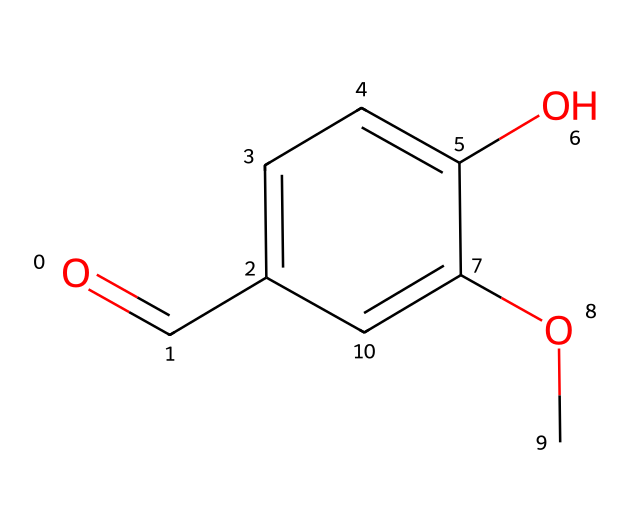What is the common name of this chemical? The chemical structure corresponds to vanillin, which is a well-known flavoring and fragrance compound derived from vanilla beans.
Answer: vanillin How many carbon atoms are in this molecule? By analyzing the SMILES representation, we can count the number of 'C's. There are 8 carbon atoms present in the structure.
Answer: 8 What functional groups are present in this compound? The chemical contains a hydroxyl group (-OH), an aldehyde group (-CHO), and a methoxy group (-OCH3), which are responsible for its aroma and flavor properties.
Answer: hydroxyl, aldehyde, methoxy How many hydrogen atoms are connected to carbon atoms in this molecule? Counting the hydrogen atoms, we see that each carbon's typical valency of four is satisfied by the bonds shown and completes to a total of 8 hydrogen atoms around the carbon skeleton.
Answer: 8 What type of aroma does vanillin impart? Vanillin is known to impart a sweet and comforting aroma, often associated with vanilla scenting products used in air fresheners.
Answer: sweet What is the primary use of vanillin aside from flavoring? In addition to flavoring food products, vanillin is widely used in perfumery and scented products due to its appealing fragrance.
Answer: perfumery 